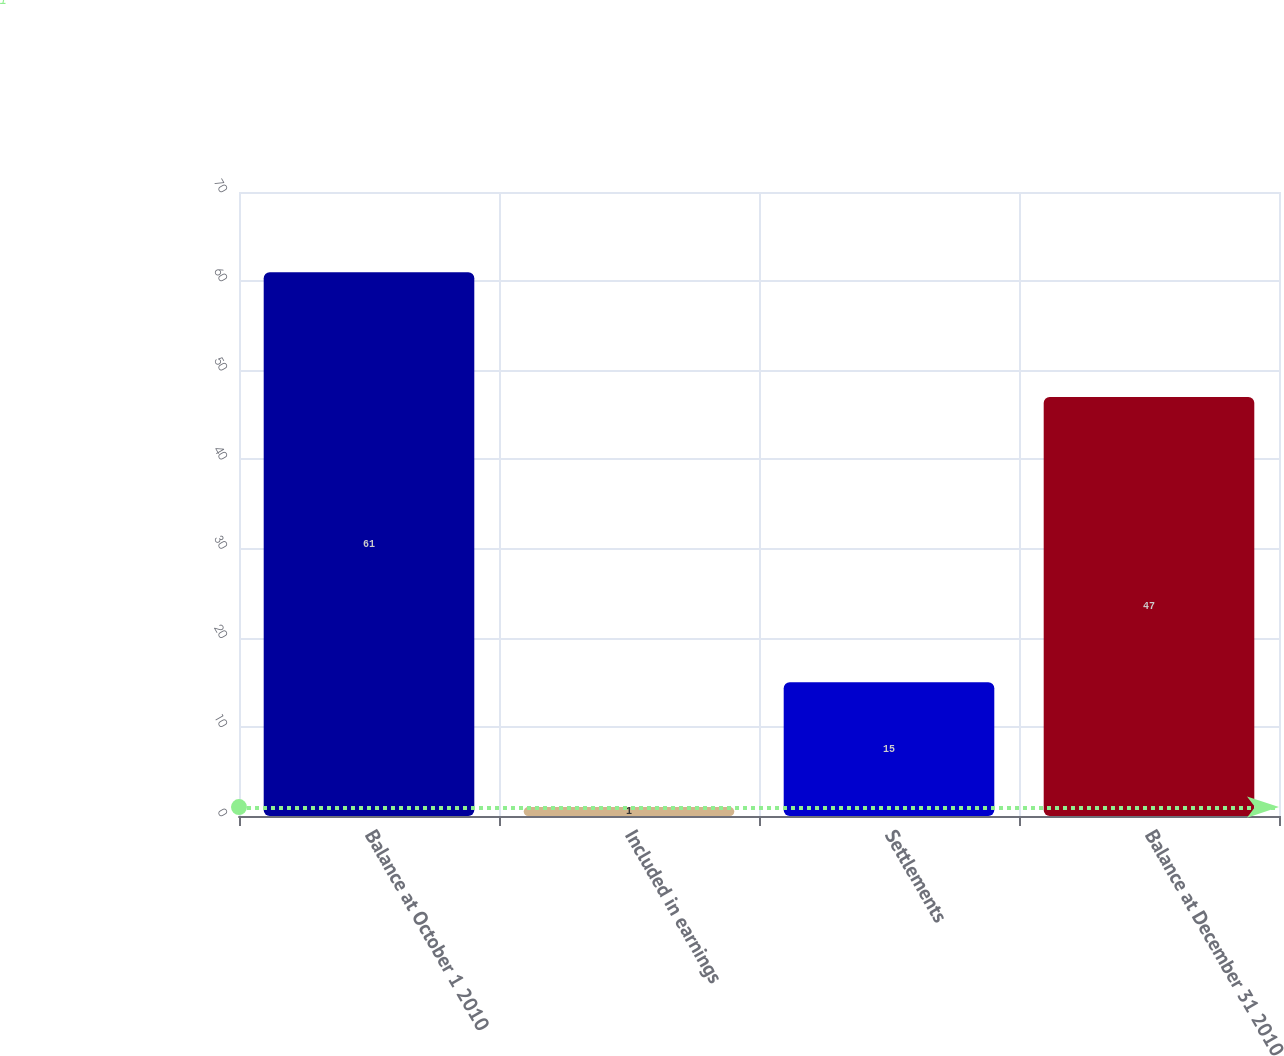Convert chart to OTSL. <chart><loc_0><loc_0><loc_500><loc_500><bar_chart><fcel>Balance at October 1 2010<fcel>Included in earnings<fcel>Settlements<fcel>Balance at December 31 2010<nl><fcel>61<fcel>1<fcel>15<fcel>47<nl></chart> 